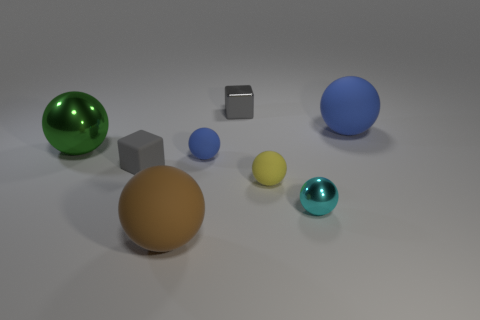Subtract all yellow spheres. How many spheres are left? 5 Subtract all small metal spheres. How many spheres are left? 5 Subtract all purple balls. Subtract all cyan blocks. How many balls are left? 6 Add 1 red metallic balls. How many objects exist? 9 Subtract all cubes. How many objects are left? 6 Add 6 small yellow balls. How many small yellow balls exist? 7 Subtract 2 blue spheres. How many objects are left? 6 Subtract all tiny gray matte cubes. Subtract all tiny gray shiny cubes. How many objects are left? 6 Add 1 tiny cubes. How many tiny cubes are left? 3 